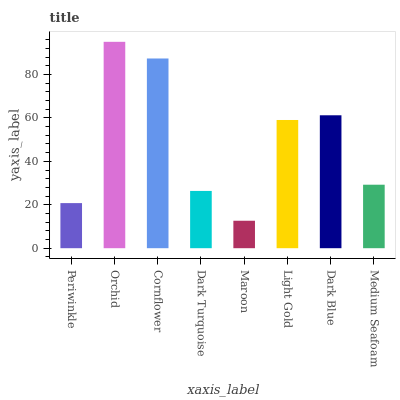Is Maroon the minimum?
Answer yes or no. Yes. Is Orchid the maximum?
Answer yes or no. Yes. Is Cornflower the minimum?
Answer yes or no. No. Is Cornflower the maximum?
Answer yes or no. No. Is Orchid greater than Cornflower?
Answer yes or no. Yes. Is Cornflower less than Orchid?
Answer yes or no. Yes. Is Cornflower greater than Orchid?
Answer yes or no. No. Is Orchid less than Cornflower?
Answer yes or no. No. Is Light Gold the high median?
Answer yes or no. Yes. Is Medium Seafoam the low median?
Answer yes or no. Yes. Is Dark Turquoise the high median?
Answer yes or no. No. Is Light Gold the low median?
Answer yes or no. No. 